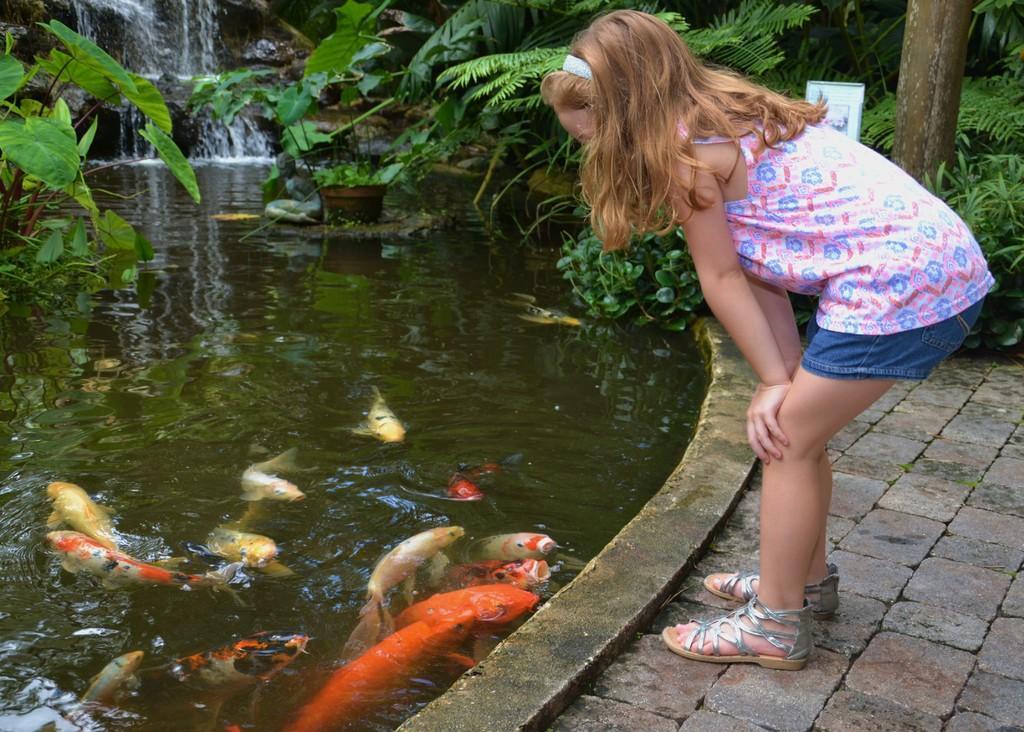In one or two sentences, can you explain what this image depicts? In this picture we can see small girl, standing in the front and watching the koi fish in the small pond. Behind there are some plants. 